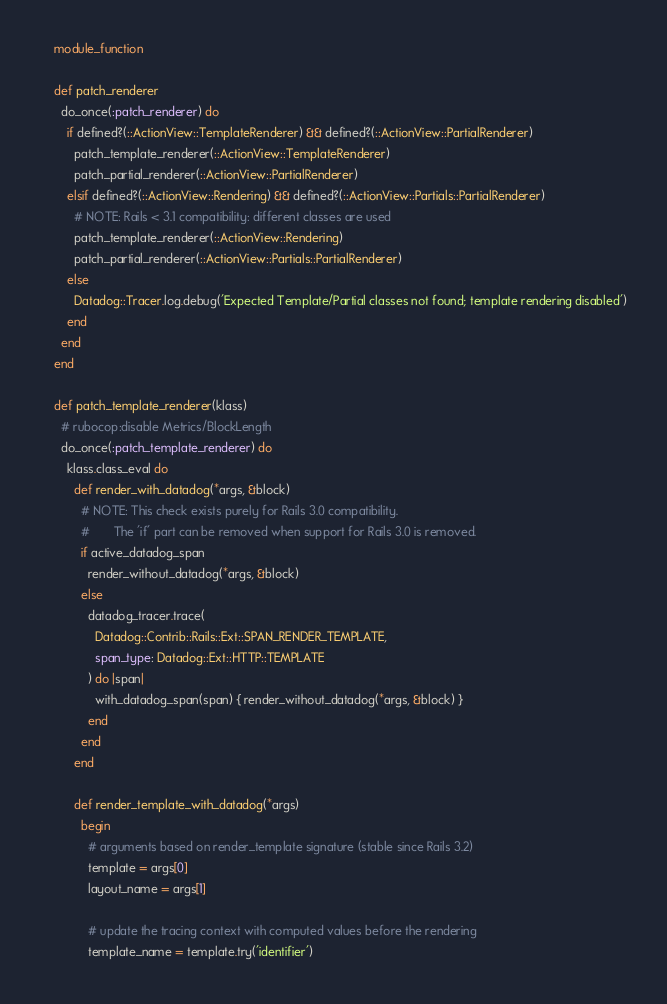<code> <loc_0><loc_0><loc_500><loc_500><_Ruby_>
    module_function

    def patch_renderer
      do_once(:patch_renderer) do
        if defined?(::ActionView::TemplateRenderer) && defined?(::ActionView::PartialRenderer)
          patch_template_renderer(::ActionView::TemplateRenderer)
          patch_partial_renderer(::ActionView::PartialRenderer)
        elsif defined?(::ActionView::Rendering) && defined?(::ActionView::Partials::PartialRenderer)
          # NOTE: Rails < 3.1 compatibility: different classes are used
          patch_template_renderer(::ActionView::Rendering)
          patch_partial_renderer(::ActionView::Partials::PartialRenderer)
        else
          Datadog::Tracer.log.debug('Expected Template/Partial classes not found; template rendering disabled')
        end
      end
    end

    def patch_template_renderer(klass)
      # rubocop:disable Metrics/BlockLength
      do_once(:patch_template_renderer) do
        klass.class_eval do
          def render_with_datadog(*args, &block)
            # NOTE: This check exists purely for Rails 3.0 compatibility.
            #       The 'if' part can be removed when support for Rails 3.0 is removed.
            if active_datadog_span
              render_without_datadog(*args, &block)
            else
              datadog_tracer.trace(
                Datadog::Contrib::Rails::Ext::SPAN_RENDER_TEMPLATE,
                span_type: Datadog::Ext::HTTP::TEMPLATE
              ) do |span|
                with_datadog_span(span) { render_without_datadog(*args, &block) }
              end
            end
          end

          def render_template_with_datadog(*args)
            begin
              # arguments based on render_template signature (stable since Rails 3.2)
              template = args[0]
              layout_name = args[1]

              # update the tracing context with computed values before the rendering
              template_name = template.try('identifier')</code> 